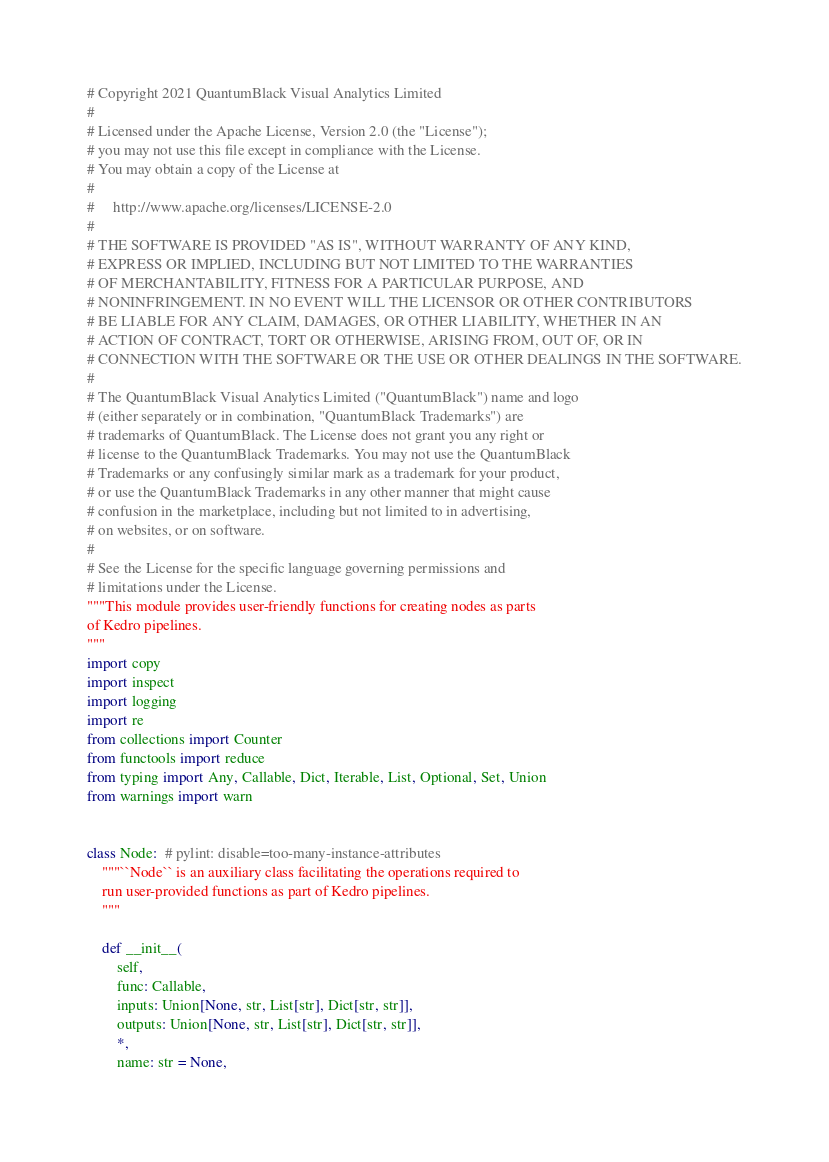Convert code to text. <code><loc_0><loc_0><loc_500><loc_500><_Python_># Copyright 2021 QuantumBlack Visual Analytics Limited
#
# Licensed under the Apache License, Version 2.0 (the "License");
# you may not use this file except in compliance with the License.
# You may obtain a copy of the License at
#
#     http://www.apache.org/licenses/LICENSE-2.0
#
# THE SOFTWARE IS PROVIDED "AS IS", WITHOUT WARRANTY OF ANY KIND,
# EXPRESS OR IMPLIED, INCLUDING BUT NOT LIMITED TO THE WARRANTIES
# OF MERCHANTABILITY, FITNESS FOR A PARTICULAR PURPOSE, AND
# NONINFRINGEMENT. IN NO EVENT WILL THE LICENSOR OR OTHER CONTRIBUTORS
# BE LIABLE FOR ANY CLAIM, DAMAGES, OR OTHER LIABILITY, WHETHER IN AN
# ACTION OF CONTRACT, TORT OR OTHERWISE, ARISING FROM, OUT OF, OR IN
# CONNECTION WITH THE SOFTWARE OR THE USE OR OTHER DEALINGS IN THE SOFTWARE.
#
# The QuantumBlack Visual Analytics Limited ("QuantumBlack") name and logo
# (either separately or in combination, "QuantumBlack Trademarks") are
# trademarks of QuantumBlack. The License does not grant you any right or
# license to the QuantumBlack Trademarks. You may not use the QuantumBlack
# Trademarks or any confusingly similar mark as a trademark for your product,
# or use the QuantumBlack Trademarks in any other manner that might cause
# confusion in the marketplace, including but not limited to in advertising,
# on websites, or on software.
#
# See the License for the specific language governing permissions and
# limitations under the License.
"""This module provides user-friendly functions for creating nodes as parts
of Kedro pipelines.
"""
import copy
import inspect
import logging
import re
from collections import Counter
from functools import reduce
from typing import Any, Callable, Dict, Iterable, List, Optional, Set, Union
from warnings import warn


class Node:  # pylint: disable=too-many-instance-attributes
    """``Node`` is an auxiliary class facilitating the operations required to
    run user-provided functions as part of Kedro pipelines.
    """

    def __init__(
        self,
        func: Callable,
        inputs: Union[None, str, List[str], Dict[str, str]],
        outputs: Union[None, str, List[str], Dict[str, str]],
        *,
        name: str = None,</code> 